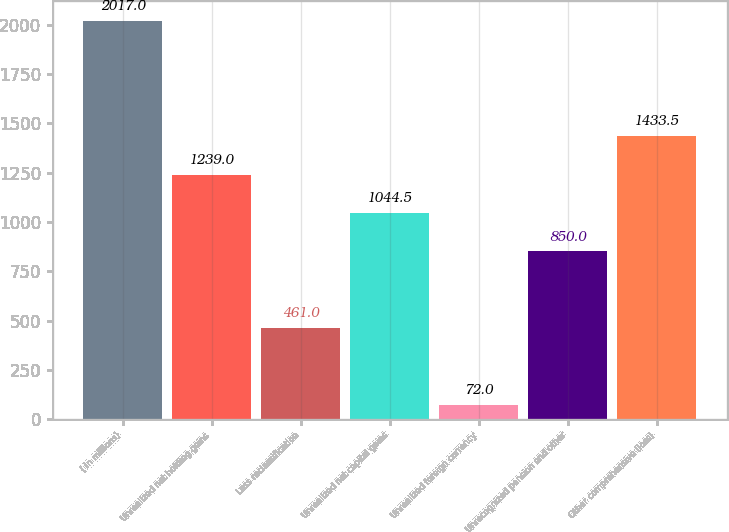Convert chart. <chart><loc_0><loc_0><loc_500><loc_500><bar_chart><fcel>( in millions)<fcel>Unrealized net holding gains<fcel>Less reclassification<fcel>Unrealized net capital gains<fcel>Unrealized foreign currency<fcel>Unrecognized pension and other<fcel>Other comprehensive (loss)<nl><fcel>2017<fcel>1239<fcel>461<fcel>1044.5<fcel>72<fcel>850<fcel>1433.5<nl></chart> 